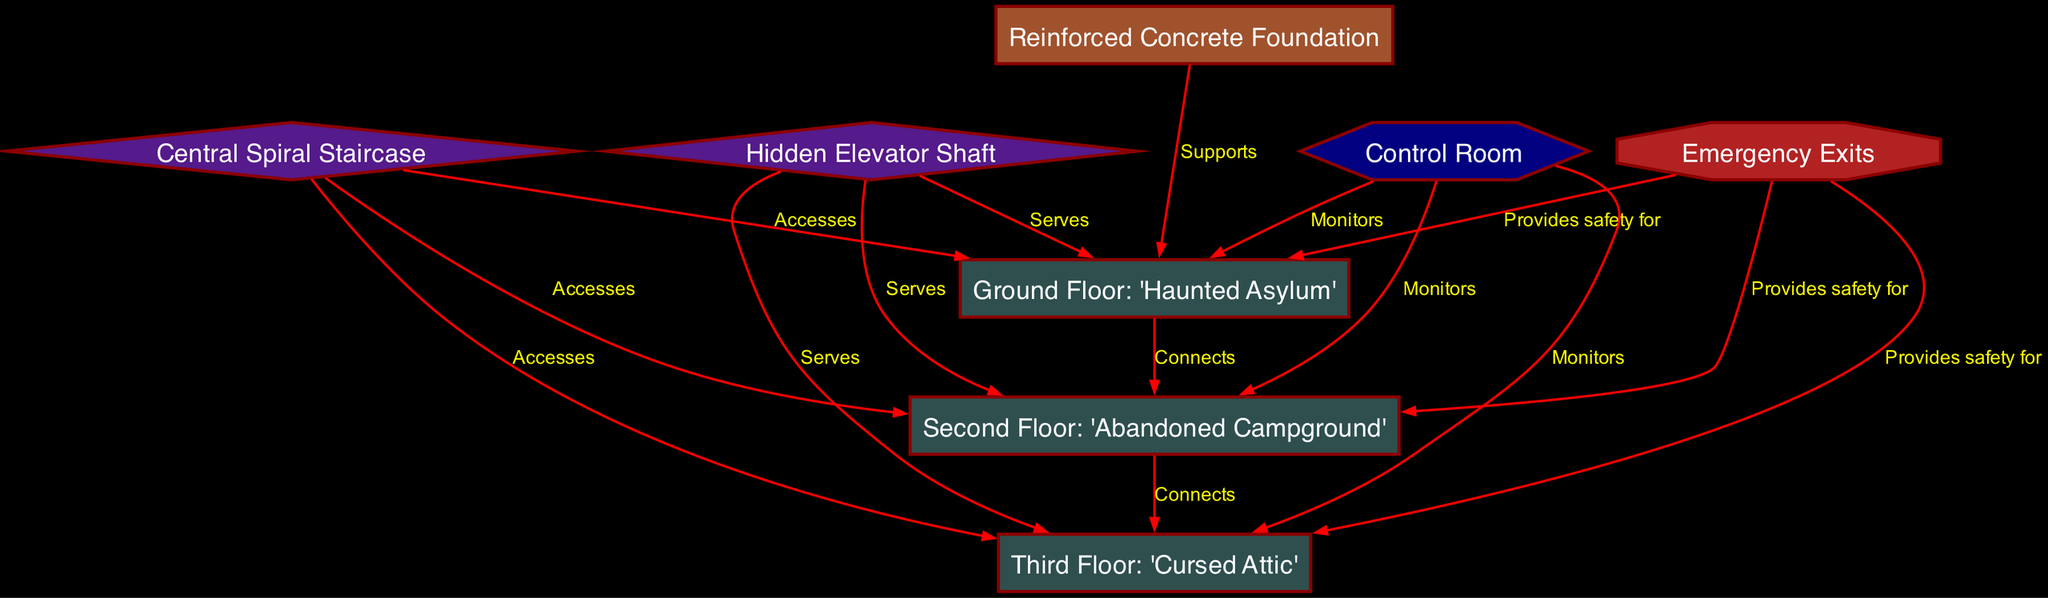What is the label of the first level? The first level is labeled as "Ground Floor: 'Haunted Asylum.'" This information is retrieved by locating the node corresponding to the first level in the diagram.
Answer: Ground Floor: 'Haunted Asylum' How many levels are in the escape room? The diagram shows three distinct levels indicated by their corresponding nodes (level1, level2, level3). Therefore, the count is based on identifying these nodes.
Answer: 3 What connects the first and second levels? The edge labeled "Connects" between level1 and level2 indicates their direct relationship. The terms and connections among nodes provide this information.
Answer: Connects Which node serves all levels? The node named "Hidden Elevator Shaft" serves as a connection to all three levels according to the edges that link it to level1, level2, and level3.
Answer: Hidden Elevator Shaft What is the function of the "Control Room"? The "Control Room" monitors all three levels—a relation clearly shown by the edges directed from the control node to each level node.
Answer: Monitors What shape is used for emergency exits? The emergency exits are represented as octagons according to their node definition in the diagram.
Answer: Octagon Which nodes are accessed via the central spiral staircase? The central spiral staircase accesses level1, level2, and level3, according to the edges leading from the staircase node to each level node.
Answer: level1, level2, level3 What provides safety for all levels? The node referred to as "Emergency Exits" provides safety for level1, level2, and level3, as indicated by the respective connections shown in the diagram.
Answer: Emergency Exits Which material constitutes the foundation? The foundation is labeled as "Reinforced Concrete Foundation," providing the basic structural support for the entire escape room.
Answer: Reinforced Concrete Foundation 